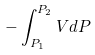<formula> <loc_0><loc_0><loc_500><loc_500>- \int _ { P _ { 1 } } ^ { P _ { 2 } } V d P</formula> 